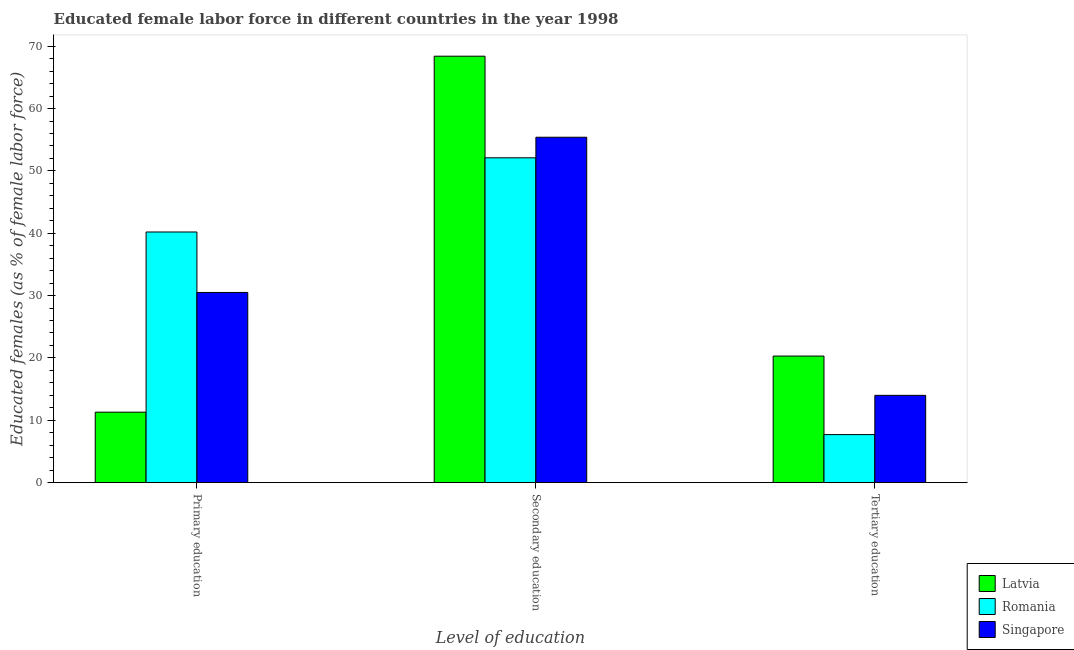How many groups of bars are there?
Your answer should be very brief. 3. How many bars are there on the 3rd tick from the left?
Provide a short and direct response. 3. What is the label of the 2nd group of bars from the left?
Your response must be concise. Secondary education. What is the percentage of female labor force who received secondary education in Latvia?
Provide a short and direct response. 68.4. Across all countries, what is the maximum percentage of female labor force who received tertiary education?
Your answer should be compact. 20.3. Across all countries, what is the minimum percentage of female labor force who received primary education?
Ensure brevity in your answer.  11.3. In which country was the percentage of female labor force who received secondary education maximum?
Offer a terse response. Latvia. In which country was the percentage of female labor force who received tertiary education minimum?
Ensure brevity in your answer.  Romania. What is the total percentage of female labor force who received primary education in the graph?
Your answer should be very brief. 82. What is the difference between the percentage of female labor force who received primary education in Romania and that in Latvia?
Provide a short and direct response. 28.9. What is the difference between the percentage of female labor force who received primary education in Singapore and the percentage of female labor force who received tertiary education in Romania?
Provide a succinct answer. 22.8. What is the average percentage of female labor force who received primary education per country?
Offer a very short reply. 27.33. What is the difference between the percentage of female labor force who received primary education and percentage of female labor force who received tertiary education in Romania?
Give a very brief answer. 32.5. What is the ratio of the percentage of female labor force who received secondary education in Romania to that in Singapore?
Make the answer very short. 0.94. Is the difference between the percentage of female labor force who received secondary education in Singapore and Romania greater than the difference between the percentage of female labor force who received tertiary education in Singapore and Romania?
Your answer should be compact. No. What is the difference between the highest and the second highest percentage of female labor force who received primary education?
Ensure brevity in your answer.  9.7. What is the difference between the highest and the lowest percentage of female labor force who received secondary education?
Your answer should be very brief. 16.3. Is the sum of the percentage of female labor force who received primary education in Romania and Latvia greater than the maximum percentage of female labor force who received tertiary education across all countries?
Offer a very short reply. Yes. What does the 2nd bar from the left in Tertiary education represents?
Your response must be concise. Romania. What does the 2nd bar from the right in Primary education represents?
Give a very brief answer. Romania. Is it the case that in every country, the sum of the percentage of female labor force who received primary education and percentage of female labor force who received secondary education is greater than the percentage of female labor force who received tertiary education?
Ensure brevity in your answer.  Yes. How many countries are there in the graph?
Provide a short and direct response. 3. What is the difference between two consecutive major ticks on the Y-axis?
Provide a short and direct response. 10. Does the graph contain any zero values?
Your answer should be very brief. No. Does the graph contain grids?
Provide a succinct answer. No. Where does the legend appear in the graph?
Your response must be concise. Bottom right. What is the title of the graph?
Your answer should be very brief. Educated female labor force in different countries in the year 1998. What is the label or title of the X-axis?
Provide a short and direct response. Level of education. What is the label or title of the Y-axis?
Offer a very short reply. Educated females (as % of female labor force). What is the Educated females (as % of female labor force) in Latvia in Primary education?
Ensure brevity in your answer.  11.3. What is the Educated females (as % of female labor force) in Romania in Primary education?
Your answer should be very brief. 40.2. What is the Educated females (as % of female labor force) in Singapore in Primary education?
Your answer should be very brief. 30.5. What is the Educated females (as % of female labor force) in Latvia in Secondary education?
Your response must be concise. 68.4. What is the Educated females (as % of female labor force) in Romania in Secondary education?
Keep it short and to the point. 52.1. What is the Educated females (as % of female labor force) in Singapore in Secondary education?
Give a very brief answer. 55.4. What is the Educated females (as % of female labor force) in Latvia in Tertiary education?
Ensure brevity in your answer.  20.3. What is the Educated females (as % of female labor force) in Romania in Tertiary education?
Your answer should be compact. 7.7. What is the Educated females (as % of female labor force) of Singapore in Tertiary education?
Your answer should be compact. 14. Across all Level of education, what is the maximum Educated females (as % of female labor force) in Latvia?
Offer a terse response. 68.4. Across all Level of education, what is the maximum Educated females (as % of female labor force) in Romania?
Make the answer very short. 52.1. Across all Level of education, what is the maximum Educated females (as % of female labor force) of Singapore?
Your answer should be very brief. 55.4. Across all Level of education, what is the minimum Educated females (as % of female labor force) of Latvia?
Your answer should be compact. 11.3. Across all Level of education, what is the minimum Educated females (as % of female labor force) of Romania?
Your answer should be very brief. 7.7. What is the total Educated females (as % of female labor force) of Latvia in the graph?
Your answer should be very brief. 100. What is the total Educated females (as % of female labor force) of Singapore in the graph?
Offer a very short reply. 99.9. What is the difference between the Educated females (as % of female labor force) in Latvia in Primary education and that in Secondary education?
Make the answer very short. -57.1. What is the difference between the Educated females (as % of female labor force) in Singapore in Primary education and that in Secondary education?
Offer a terse response. -24.9. What is the difference between the Educated females (as % of female labor force) of Latvia in Primary education and that in Tertiary education?
Give a very brief answer. -9. What is the difference between the Educated females (as % of female labor force) in Romania in Primary education and that in Tertiary education?
Make the answer very short. 32.5. What is the difference between the Educated females (as % of female labor force) in Latvia in Secondary education and that in Tertiary education?
Your answer should be very brief. 48.1. What is the difference between the Educated females (as % of female labor force) of Romania in Secondary education and that in Tertiary education?
Give a very brief answer. 44.4. What is the difference between the Educated females (as % of female labor force) of Singapore in Secondary education and that in Tertiary education?
Give a very brief answer. 41.4. What is the difference between the Educated females (as % of female labor force) of Latvia in Primary education and the Educated females (as % of female labor force) of Romania in Secondary education?
Give a very brief answer. -40.8. What is the difference between the Educated females (as % of female labor force) in Latvia in Primary education and the Educated females (as % of female labor force) in Singapore in Secondary education?
Your answer should be compact. -44.1. What is the difference between the Educated females (as % of female labor force) in Romania in Primary education and the Educated females (as % of female labor force) in Singapore in Secondary education?
Your response must be concise. -15.2. What is the difference between the Educated females (as % of female labor force) in Latvia in Primary education and the Educated females (as % of female labor force) in Singapore in Tertiary education?
Your answer should be compact. -2.7. What is the difference between the Educated females (as % of female labor force) of Romania in Primary education and the Educated females (as % of female labor force) of Singapore in Tertiary education?
Your response must be concise. 26.2. What is the difference between the Educated females (as % of female labor force) of Latvia in Secondary education and the Educated females (as % of female labor force) of Romania in Tertiary education?
Your response must be concise. 60.7. What is the difference between the Educated females (as % of female labor force) of Latvia in Secondary education and the Educated females (as % of female labor force) of Singapore in Tertiary education?
Offer a terse response. 54.4. What is the difference between the Educated females (as % of female labor force) in Romania in Secondary education and the Educated females (as % of female labor force) in Singapore in Tertiary education?
Provide a short and direct response. 38.1. What is the average Educated females (as % of female labor force) in Latvia per Level of education?
Make the answer very short. 33.33. What is the average Educated females (as % of female labor force) of Romania per Level of education?
Give a very brief answer. 33.33. What is the average Educated females (as % of female labor force) in Singapore per Level of education?
Your answer should be very brief. 33.3. What is the difference between the Educated females (as % of female labor force) in Latvia and Educated females (as % of female labor force) in Romania in Primary education?
Provide a short and direct response. -28.9. What is the difference between the Educated females (as % of female labor force) of Latvia and Educated females (as % of female labor force) of Singapore in Primary education?
Provide a succinct answer. -19.2. What is the difference between the Educated females (as % of female labor force) in Latvia and Educated females (as % of female labor force) in Romania in Secondary education?
Keep it short and to the point. 16.3. What is the difference between the Educated females (as % of female labor force) of Latvia and Educated females (as % of female labor force) of Singapore in Secondary education?
Offer a very short reply. 13. What is the difference between the Educated females (as % of female labor force) in Latvia and Educated females (as % of female labor force) in Romania in Tertiary education?
Your response must be concise. 12.6. What is the ratio of the Educated females (as % of female labor force) in Latvia in Primary education to that in Secondary education?
Provide a short and direct response. 0.17. What is the ratio of the Educated females (as % of female labor force) of Romania in Primary education to that in Secondary education?
Provide a short and direct response. 0.77. What is the ratio of the Educated females (as % of female labor force) in Singapore in Primary education to that in Secondary education?
Offer a terse response. 0.55. What is the ratio of the Educated females (as % of female labor force) of Latvia in Primary education to that in Tertiary education?
Make the answer very short. 0.56. What is the ratio of the Educated females (as % of female labor force) in Romania in Primary education to that in Tertiary education?
Offer a terse response. 5.22. What is the ratio of the Educated females (as % of female labor force) in Singapore in Primary education to that in Tertiary education?
Make the answer very short. 2.18. What is the ratio of the Educated females (as % of female labor force) of Latvia in Secondary education to that in Tertiary education?
Ensure brevity in your answer.  3.37. What is the ratio of the Educated females (as % of female labor force) in Romania in Secondary education to that in Tertiary education?
Ensure brevity in your answer.  6.77. What is the ratio of the Educated females (as % of female labor force) of Singapore in Secondary education to that in Tertiary education?
Your answer should be very brief. 3.96. What is the difference between the highest and the second highest Educated females (as % of female labor force) of Latvia?
Your response must be concise. 48.1. What is the difference between the highest and the second highest Educated females (as % of female labor force) in Singapore?
Make the answer very short. 24.9. What is the difference between the highest and the lowest Educated females (as % of female labor force) in Latvia?
Offer a terse response. 57.1. What is the difference between the highest and the lowest Educated females (as % of female labor force) in Romania?
Keep it short and to the point. 44.4. What is the difference between the highest and the lowest Educated females (as % of female labor force) in Singapore?
Your response must be concise. 41.4. 